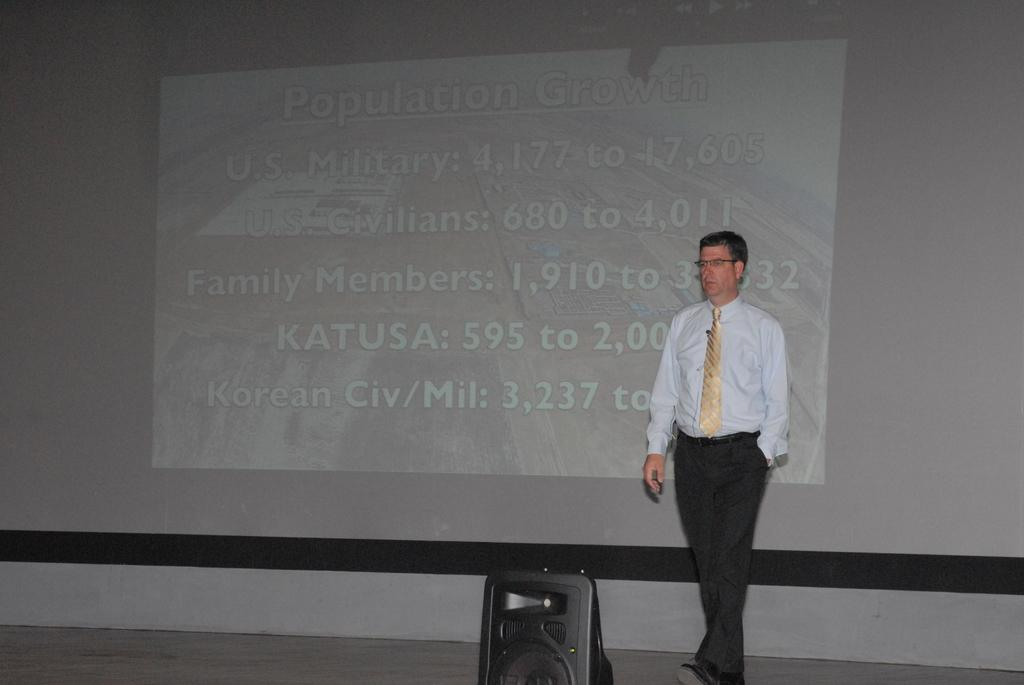Who is present in the image? There is a man in the image. What is the man wearing on his face? The man is wearing spectacles. What type of clothing is the man wearing around his neck? The man is wearing a tie. Where is the man located in the image? The man is on a stage. What can be seen in the background of the image? There is a screen in the background of the image. What is the value of the development in the image? There is no reference to a development or value in the image; it features a man on a stage with spectacles, a tie, and a screen in the background. 